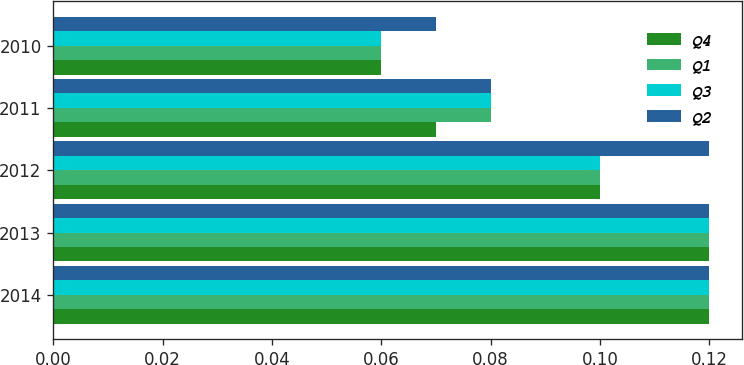<chart> <loc_0><loc_0><loc_500><loc_500><stacked_bar_chart><ecel><fcel>2014<fcel>2013<fcel>2012<fcel>2011<fcel>2010<nl><fcel>Q4<fcel>0.12<fcel>0.12<fcel>0.1<fcel>0.07<fcel>0.06<nl><fcel>Q1<fcel>0.12<fcel>0.12<fcel>0.1<fcel>0.08<fcel>0.06<nl><fcel>Q3<fcel>0.12<fcel>0.12<fcel>0.1<fcel>0.08<fcel>0.06<nl><fcel>Q2<fcel>0.12<fcel>0.12<fcel>0.12<fcel>0.08<fcel>0.07<nl></chart> 